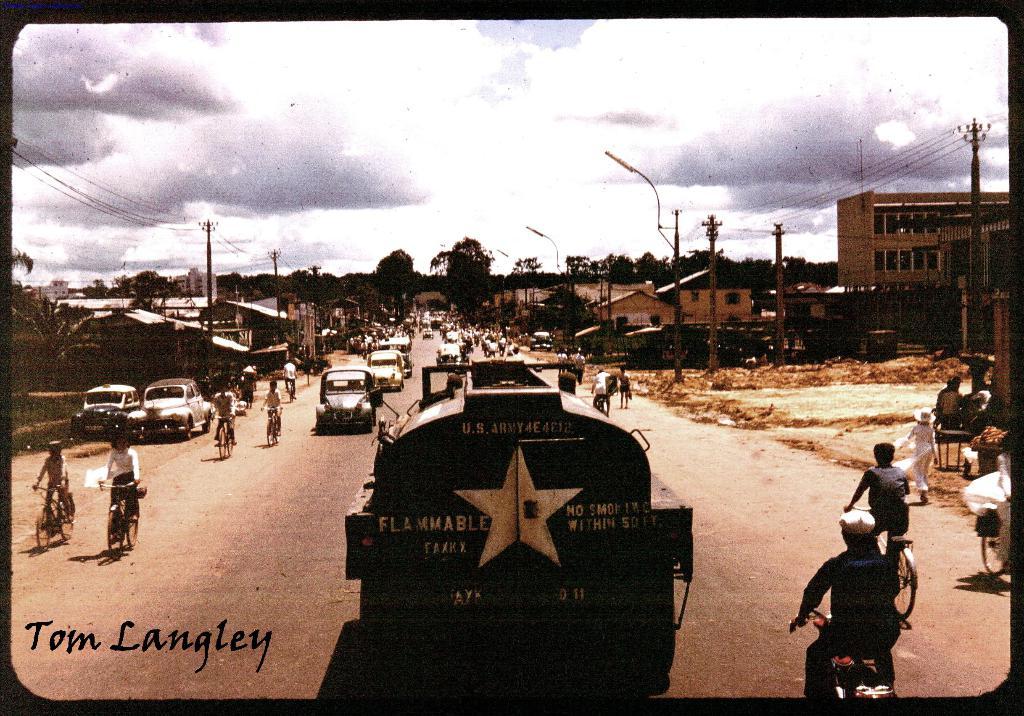Who took this photo?
Ensure brevity in your answer.  Tom langley. 